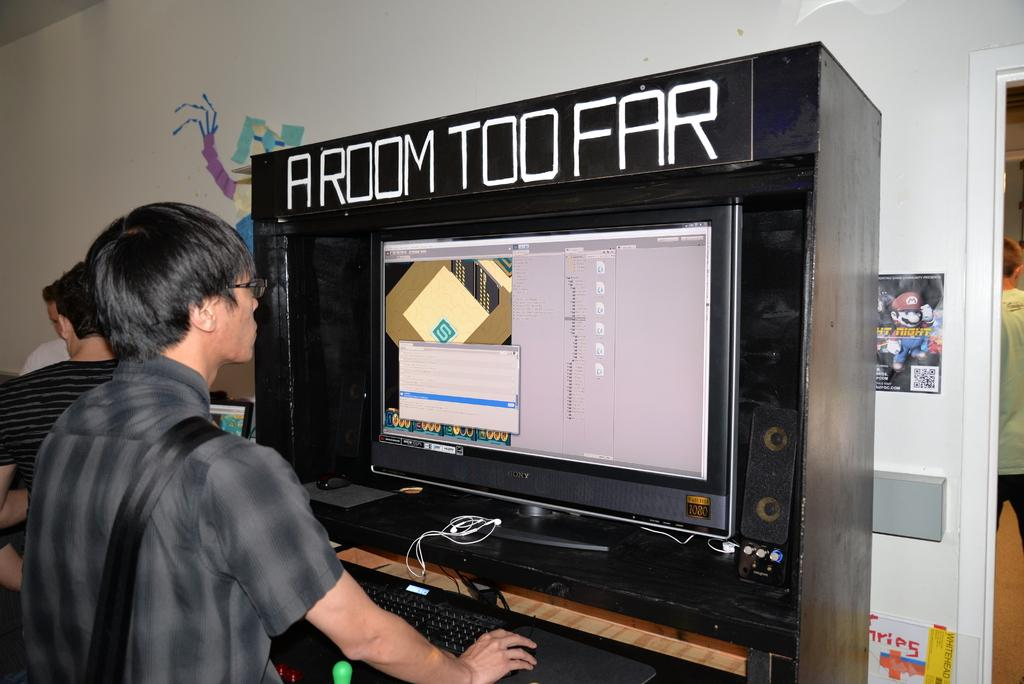<image>
Relay a brief, clear account of the picture shown. A video game is labeled A Room Too Far. 